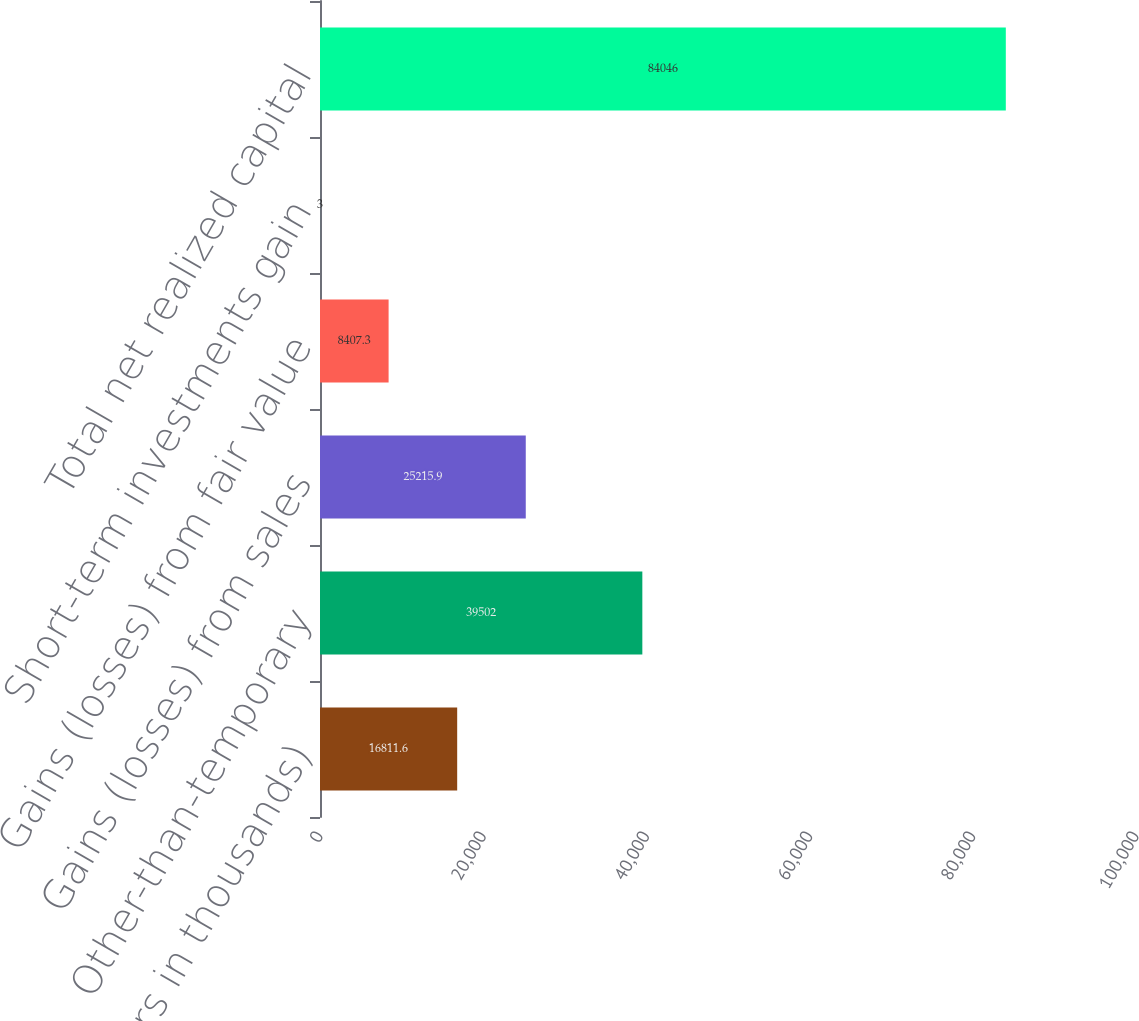<chart> <loc_0><loc_0><loc_500><loc_500><bar_chart><fcel>(Dollars in thousands)<fcel>Other-than-temporary<fcel>Gains (losses) from sales<fcel>Gains (losses) from fair value<fcel>Short-term investments gain<fcel>Total net realized capital<nl><fcel>16811.6<fcel>39502<fcel>25215.9<fcel>8407.3<fcel>3<fcel>84046<nl></chart> 